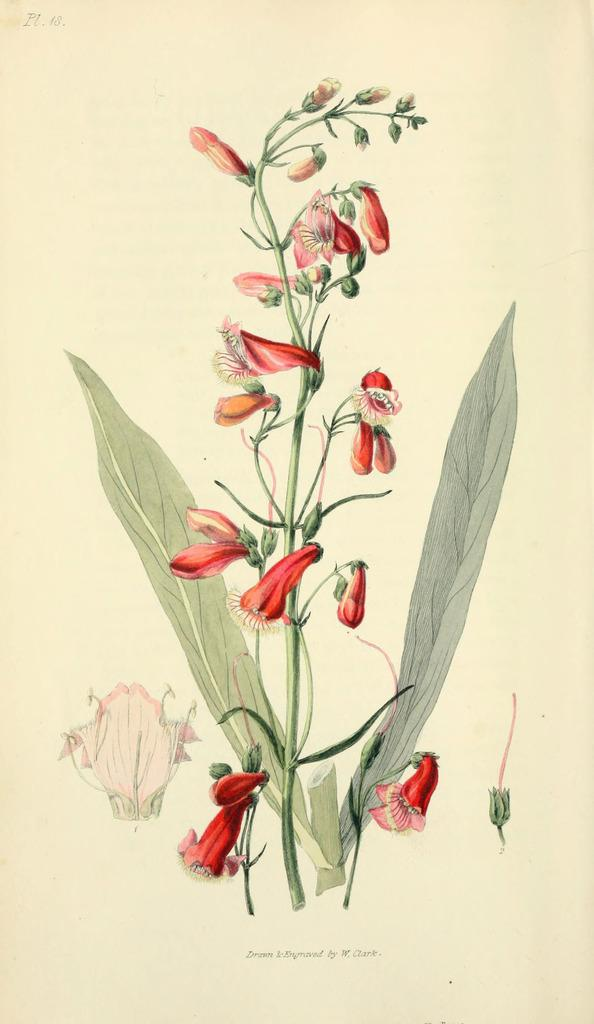What type of living organism can be seen in the image? There is a plant in the image. What specific feature of the plant is visible in the image? There are flowers in the image. What color are the flowers? The flowers are red in color. What is the color of the background in the image? The background of the image is cream-colored. Can you hear the duck crying in the image? There is no duck present in the image, so it is not possible to hear any crying. 